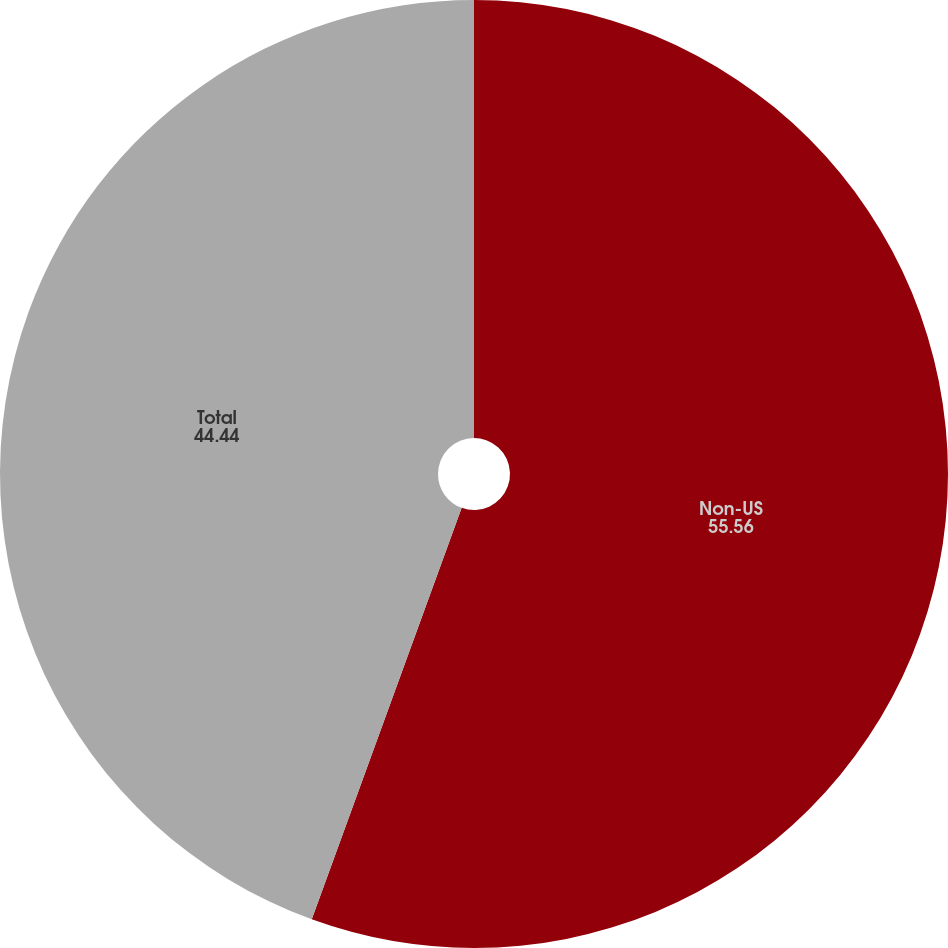<chart> <loc_0><loc_0><loc_500><loc_500><pie_chart><fcel>Non-US<fcel>Total<nl><fcel>55.56%<fcel>44.44%<nl></chart> 